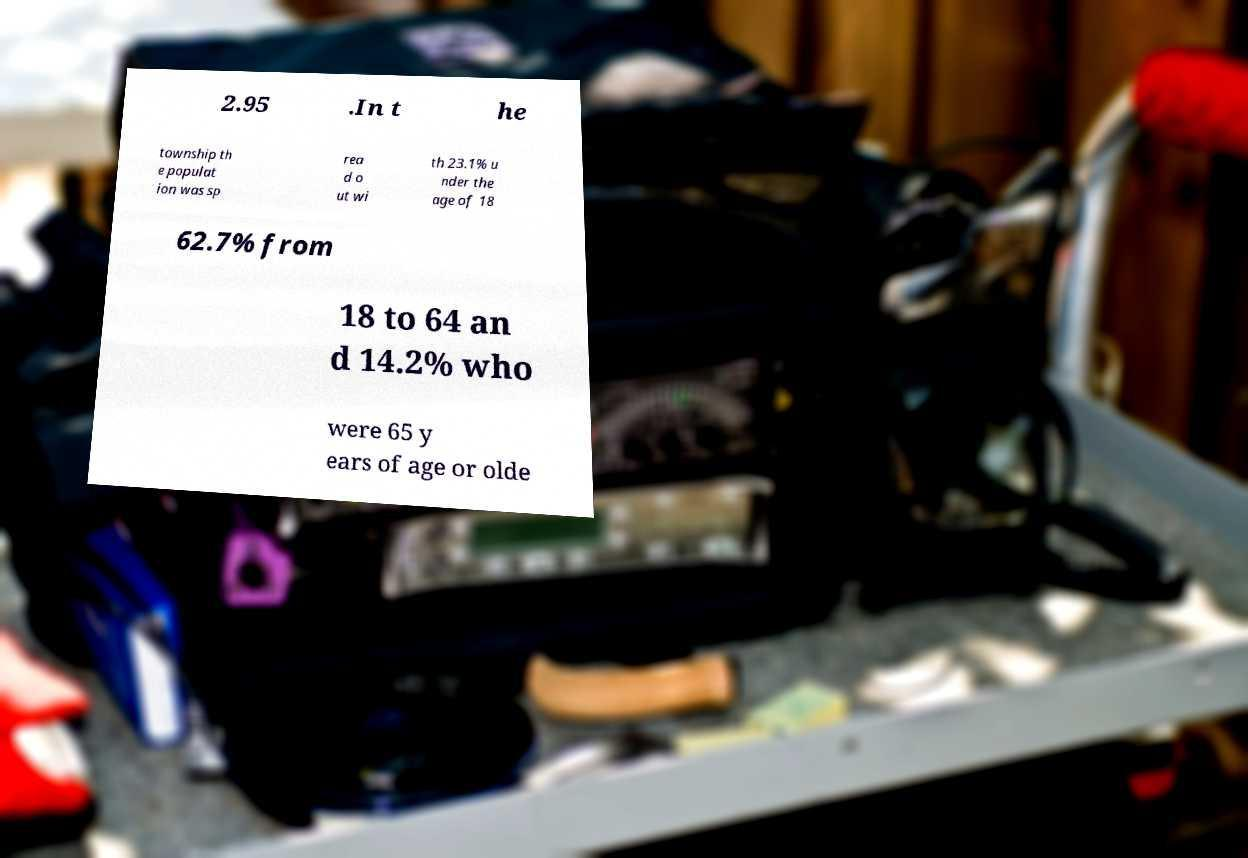What messages or text are displayed in this image? I need them in a readable, typed format. 2.95 .In t he township th e populat ion was sp rea d o ut wi th 23.1% u nder the age of 18 62.7% from 18 to 64 an d 14.2% who were 65 y ears of age or olde 